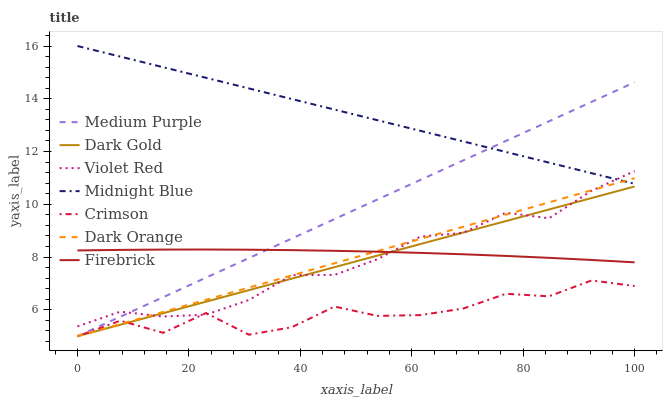Does Crimson have the minimum area under the curve?
Answer yes or no. Yes. Does Midnight Blue have the maximum area under the curve?
Answer yes or no. Yes. Does Violet Red have the minimum area under the curve?
Answer yes or no. No. Does Violet Red have the maximum area under the curve?
Answer yes or no. No. Is Dark Gold the smoothest?
Answer yes or no. Yes. Is Crimson the roughest?
Answer yes or no. Yes. Is Violet Red the smoothest?
Answer yes or no. No. Is Violet Red the roughest?
Answer yes or no. No. Does Dark Orange have the lowest value?
Answer yes or no. Yes. Does Violet Red have the lowest value?
Answer yes or no. No. Does Midnight Blue have the highest value?
Answer yes or no. Yes. Does Violet Red have the highest value?
Answer yes or no. No. Is Dark Gold less than Midnight Blue?
Answer yes or no. Yes. Is Midnight Blue greater than Firebrick?
Answer yes or no. Yes. Does Medium Purple intersect Firebrick?
Answer yes or no. Yes. Is Medium Purple less than Firebrick?
Answer yes or no. No. Is Medium Purple greater than Firebrick?
Answer yes or no. No. Does Dark Gold intersect Midnight Blue?
Answer yes or no. No. 